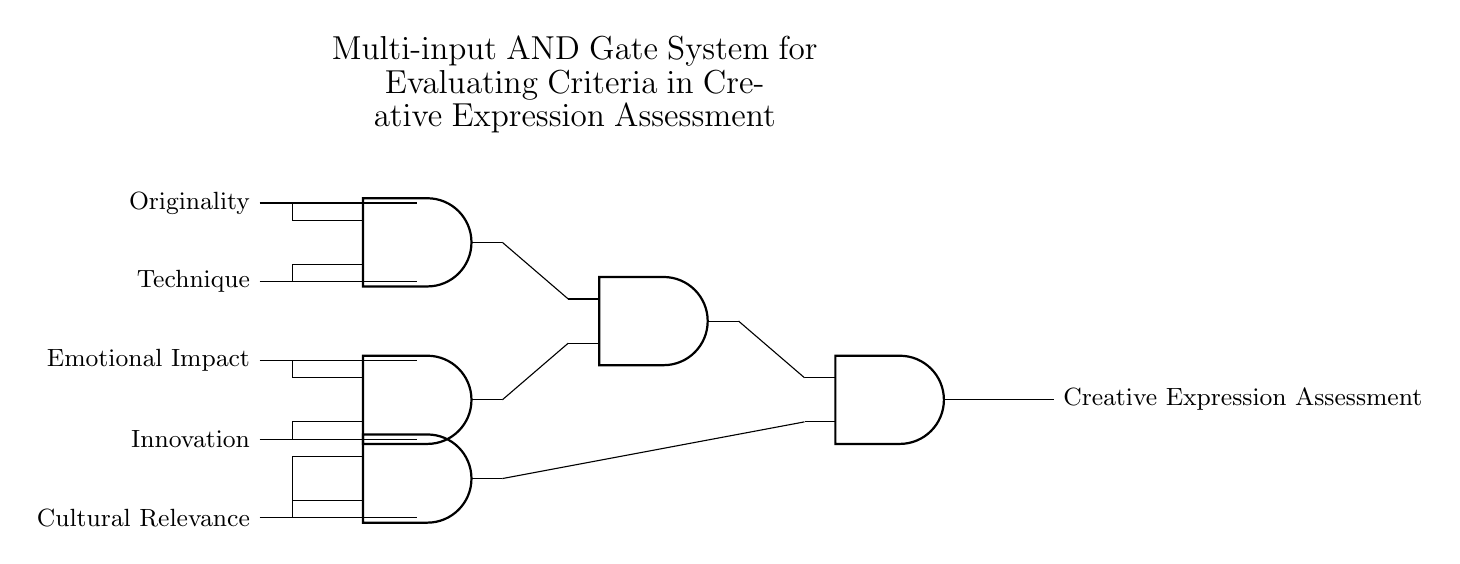What are the inputs to the AND gates? The inputs to the AND gates include Originality, Technique, Emotional Impact, Innovation, and Cultural Relevance, which are represented by the lines going into the gates.
Answer: Originality, Technique, Emotional Impact, Innovation, Cultural Relevance How many AND gates are present in the circuit? The diagram shows a total of five AND gates: three at the top level and two connected to the outputs of the first three.
Answer: Five What is the output of the final AND gate? The output of the final AND gate is labeled as “Creative Expression Assessment,” indicating that it is the evaluation result based on all criteria evaluated by the inputs.
Answer: Creative Expression Assessment Which criteria are connected to the second AND gate? The second AND gate is connected to Emotional Impact and Innovation, as indicated by the input lines leading directly into it.
Answer: Emotional Impact, Innovation How does the multi-input system influence the evaluation of Creative Expression? The multi-input nature allows the system to evaluate multiple criteria simultaneously; only when all necessary inputs are satisfied will the final output indicate a positive assessment of creative expression, demonstrating the requirement for comprehensiveness in evaluation.
Answer: Comprehensive evaluation 